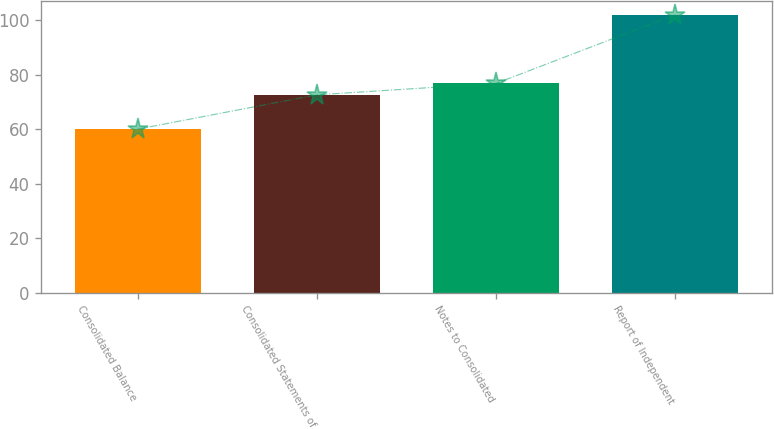<chart> <loc_0><loc_0><loc_500><loc_500><bar_chart><fcel>Consolidated Balance<fcel>Consolidated Statements of<fcel>Notes to Consolidated<fcel>Report of Independent<nl><fcel>60<fcel>72.6<fcel>76.8<fcel>102<nl></chart> 